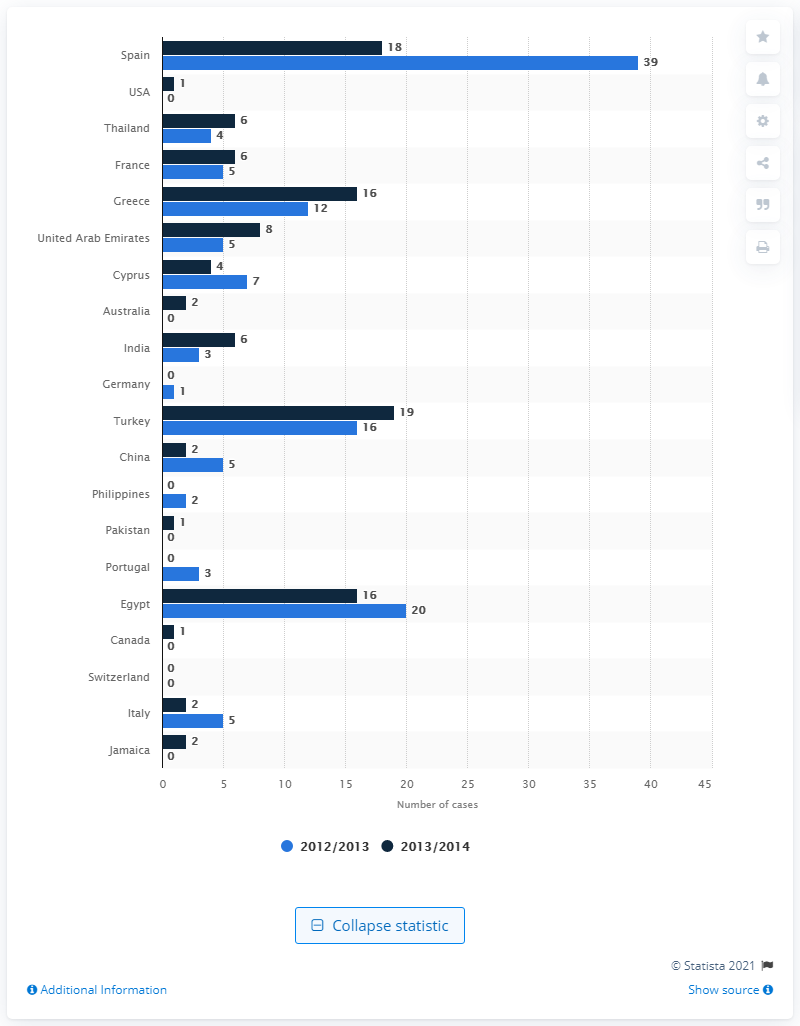Highlight a few significant elements in this photo. There were 39 reported cases of sexual assault in Spain during the years 2012 and 2013. 